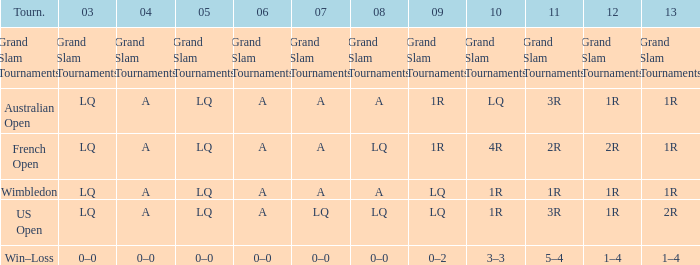Can you parse all the data within this table? {'header': ['Tourn.', '03', '04', '05', '06', '07', '08', '09', '10', '11', '12', '13'], 'rows': [['Grand Slam Tournaments', 'Grand Slam Tournaments', 'Grand Slam Tournaments', 'Grand Slam Tournaments', 'Grand Slam Tournaments', 'Grand Slam Tournaments', 'Grand Slam Tournaments', 'Grand Slam Tournaments', 'Grand Slam Tournaments', 'Grand Slam Tournaments', 'Grand Slam Tournaments', 'Grand Slam Tournaments'], ['Australian Open', 'LQ', 'A', 'LQ', 'A', 'A', 'A', '1R', 'LQ', '3R', '1R', '1R'], ['French Open', 'LQ', 'A', 'LQ', 'A', 'A', 'LQ', '1R', '4R', '2R', '2R', '1R'], ['Wimbledon', 'LQ', 'A', 'LQ', 'A', 'A', 'A', 'LQ', '1R', '1R', '1R', '1R'], ['US Open', 'LQ', 'A', 'LQ', 'A', 'LQ', 'LQ', 'LQ', '1R', '3R', '1R', '2R'], ['Win–Loss', '0–0', '0–0', '0–0', '0–0', '0–0', '0–0', '0–2', '3–3', '5–4', '1–4', '1–4']]} Which year has a 2003 of lq? 1R, 1R, LQ, LQ. 